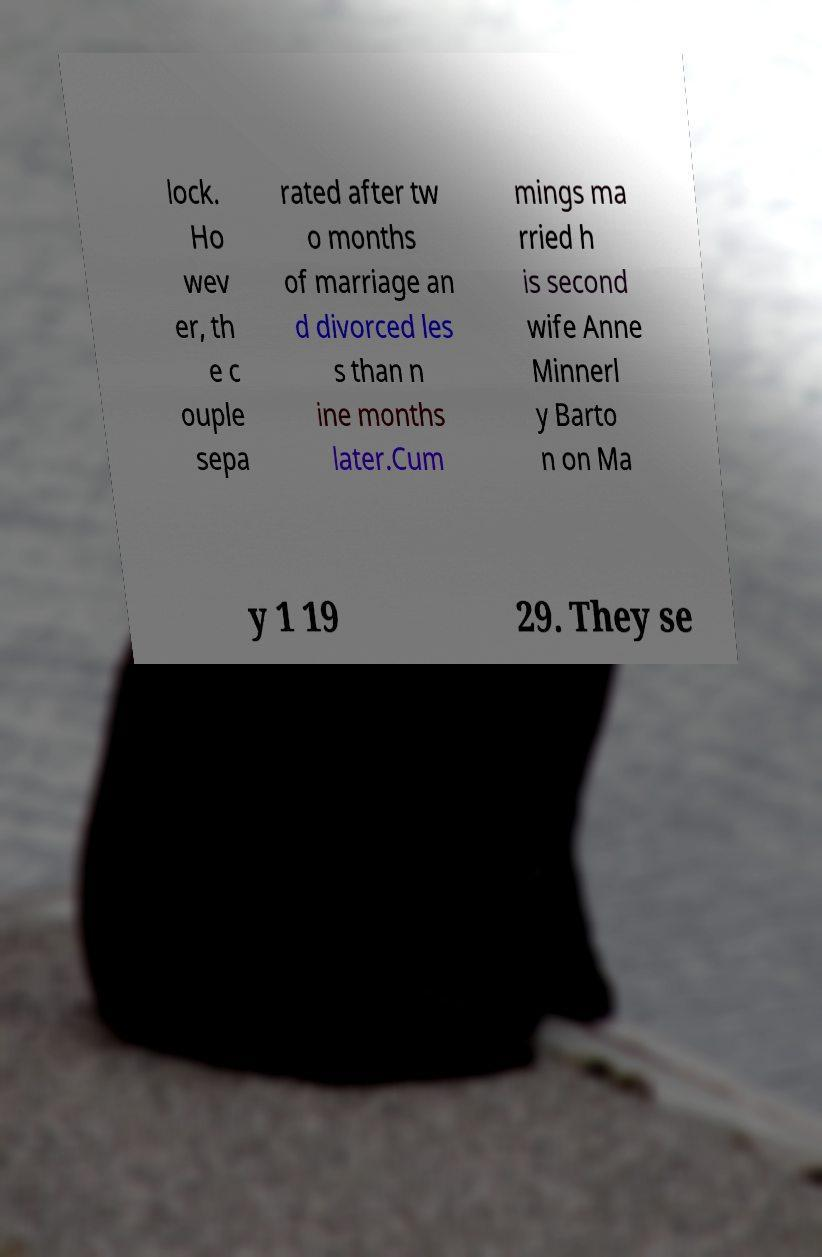Can you read and provide the text displayed in the image?This photo seems to have some interesting text. Can you extract and type it out for me? lock. Ho wev er, th e c ouple sepa rated after tw o months of marriage an d divorced les s than n ine months later.Cum mings ma rried h is second wife Anne Minnerl y Barto n on Ma y 1 19 29. They se 